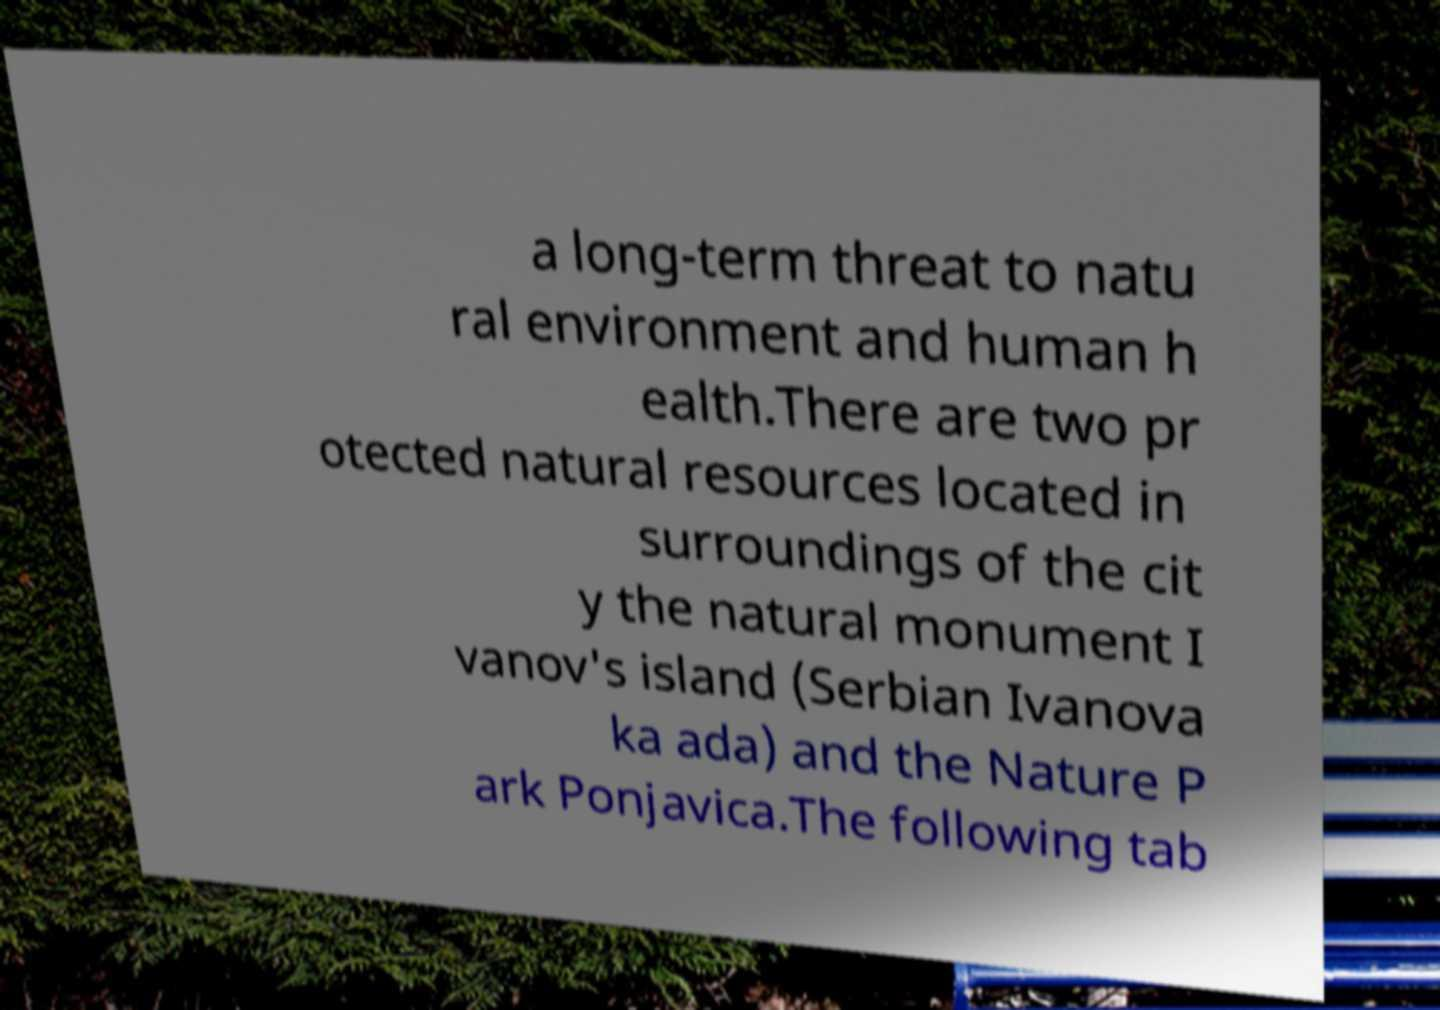Can you accurately transcribe the text from the provided image for me? a long-term threat to natu ral environment and human h ealth.There are two pr otected natural resources located in surroundings of the cit y the natural monument I vanov's island (Serbian Ivanova ka ada) and the Nature P ark Ponjavica.The following tab 